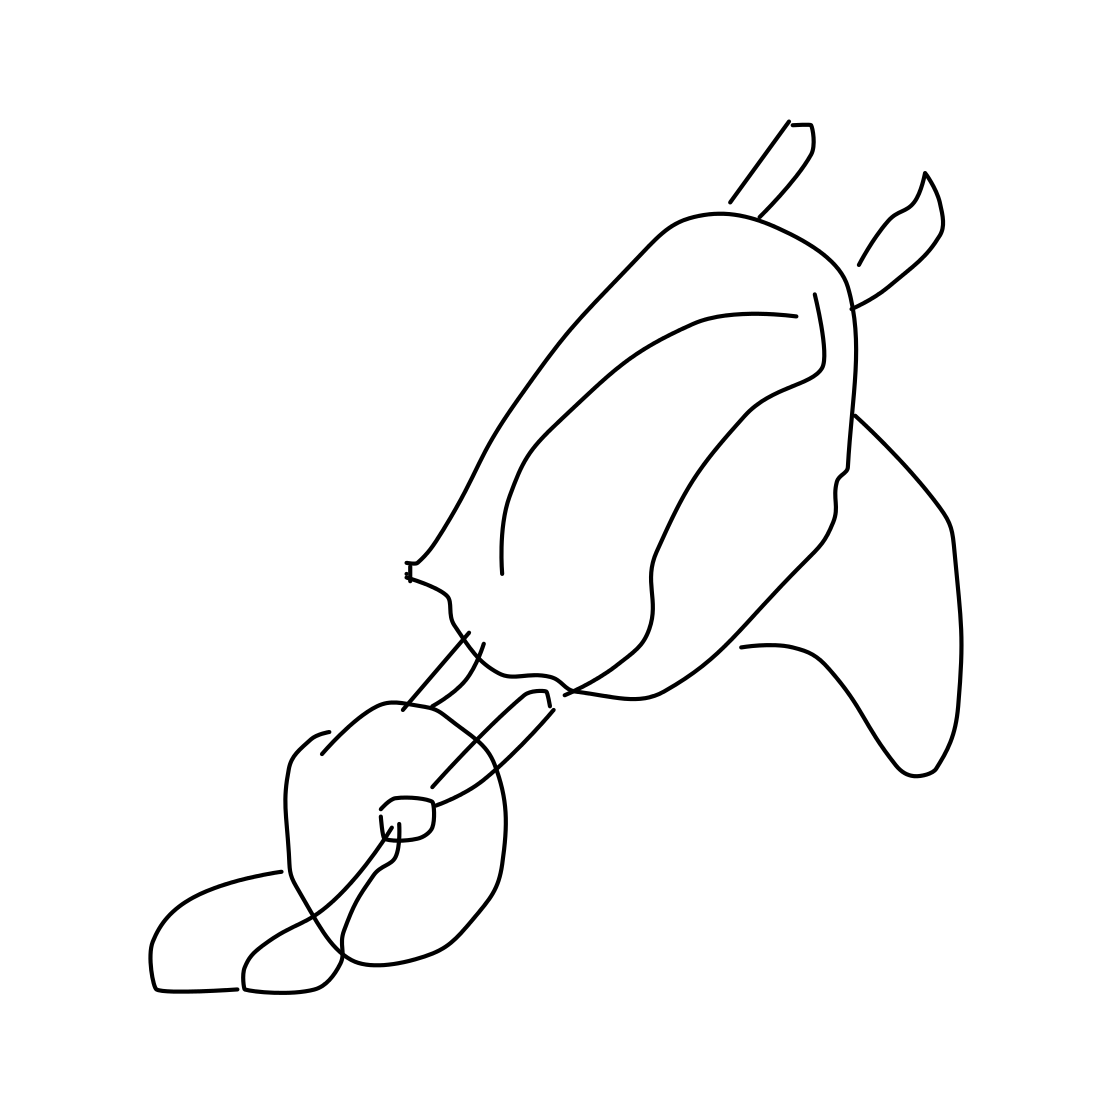If you had to guess, what medium do you think was used to create this sketch? From the evenness of the lines and the absence of any texture that might suggest paper, it looks like this sketch could have been created digitally using a drawing tablet or a computer program designed for graphic illustration. 